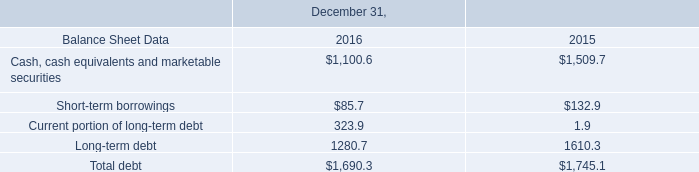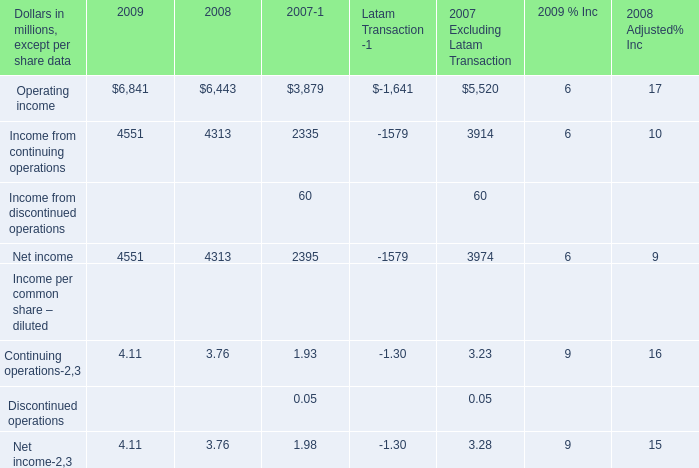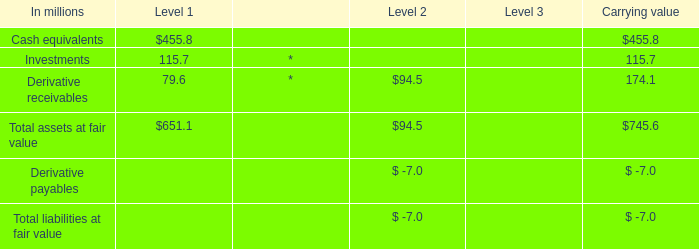What's the sum of Cash, cash equivalents and marketable securities of December 31, 2016, and Net income of 2008 ? 
Computations: (1100.6 + 4313.0)
Answer: 5413.6. 